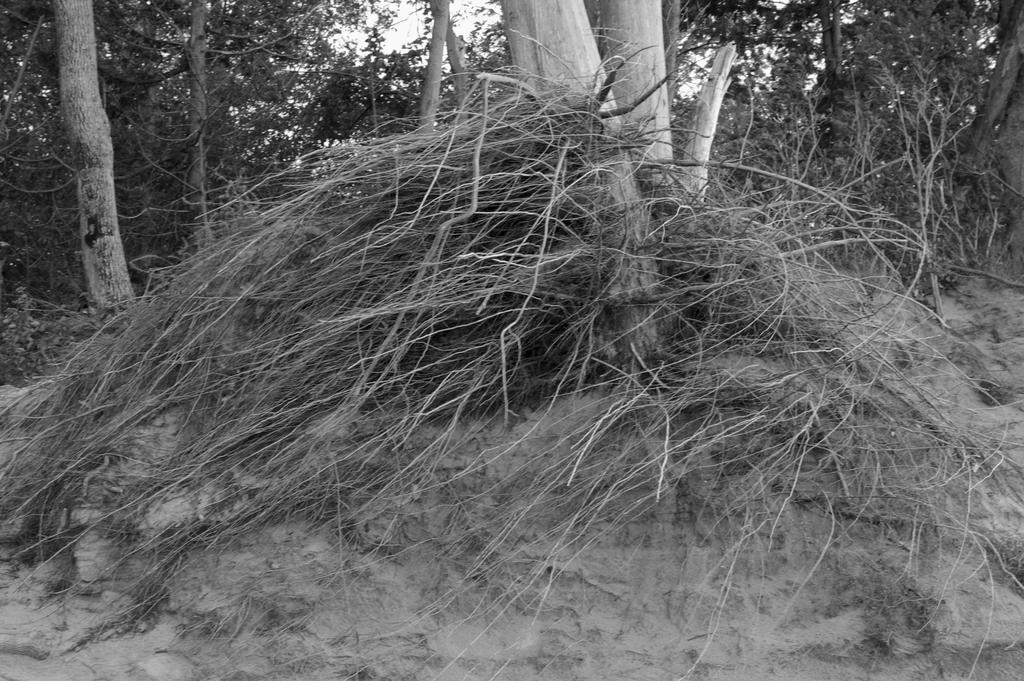Please provide a concise description of this image. This is a black and white picture. In this picture we can see trees, sky and branches. 